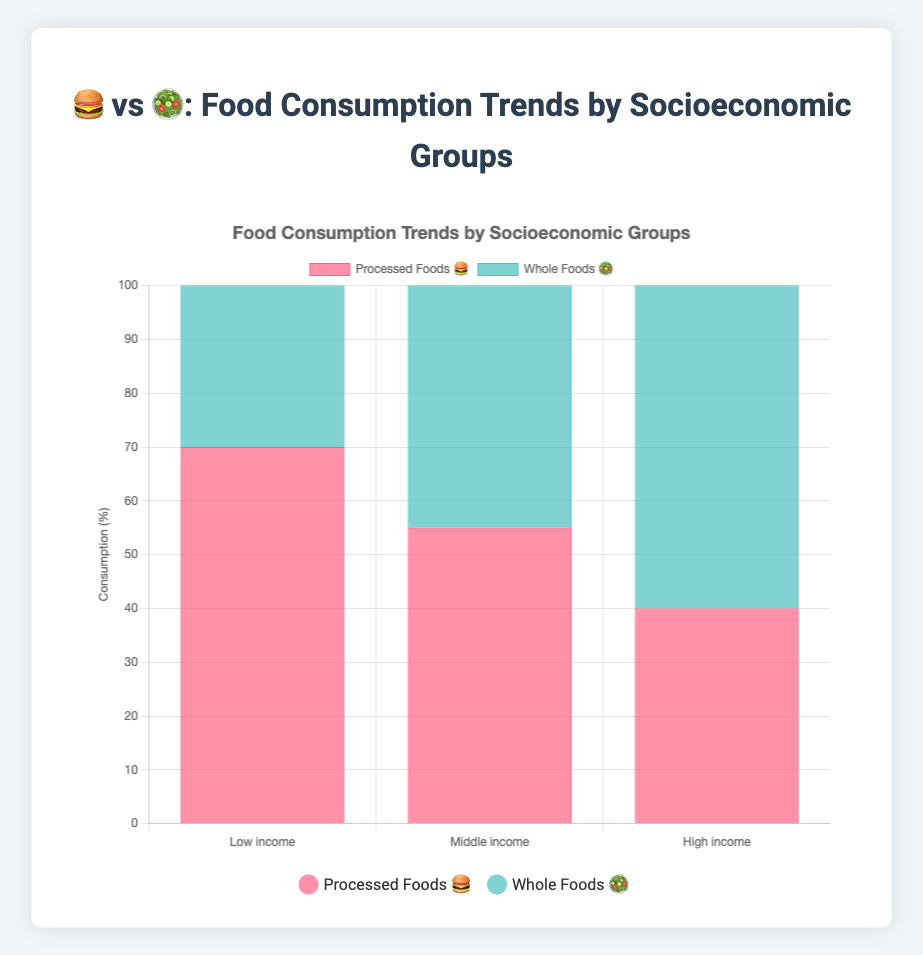What are the three socioeconomic groups shown in the figure? The figure lists "Low income", "Middle income", and "High income" under the socioeconomic groups on the x-axis.
Answer: "Low income", "Middle income", and "High income" What is the title of the figure? The title is displayed prominently at the top center of the figure and reads "🍔 vs 🥗: Food Consumption Trends by Socioeconomic Groups".
Answer: "🍔 vs 🥗: Food Consumption Trends by Socioeconomic Groups" What is the percentage of processed foods consumption for the middle income group? Refer to the bar representing processed foods for the middle income group; its height reaches 55%.
Answer: 55% Which group has the lowest obesity rate, and what is it? The tooltip shows the obesity rates for each group; the high income group has the lowest obesity rate at 15%.
Answer: High Income, 15% Compare the consumption of whole foods between low income and high income groups. The bar for whole foods in the low income group is at 30%, while in the high income group, it is 60%. High income group's consumption is higher.
Answer: High income group consumes 30% more What's the sum of processed and whole foods consumption for the high income group? Add the high income group's processed foods consumption (40%) and whole foods consumption (60%) to get the total: 40 + 60 = 100%.
Answer: 100% How do obesity rates correlate with processed foods consumption? Observing the figure, the relationship shows higher processed foods consumption is associated with higher obesity rates: low income (70% processed, 35% obesity), middle income (55% processed, 25% obesity), high income (40% processed, 15% obesity).
Answer: Higher processed foods consumption correlates with higher obesity rates Which socioeconomic group has the highest consumption of whole foods, and what is the percentage? Look at the bar for whole foods which reaches the highest point for the high income group at 60%.
Answer: High Income, 60% What is the difference in type 2 diabetes rates between the low and high income groups? Subtract the high income group's type 2 diabetes rate (5%) from the low income group's rate (12%): 12 - 5 = 7%.
Answer: 7% What is the obesity rate for the middle income group compared to the high income group? The tooltips show the middle income group's obesity rate at 25% and the high income group's at 15%, so the middle income group has a 10% higher rate.
Answer: 10% higher What's the average consumption of whole foods across all socioeconomic groups? Add the whole foods consumption for each group (30 + 45 + 60) and divide by the number of groups (3) to get the average: (30 + 45 + 60) / 3 = 45%.
Answer: 45% 